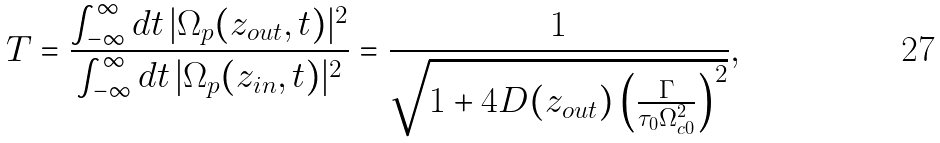<formula> <loc_0><loc_0><loc_500><loc_500>T = \frac { \int _ { - \infty } ^ { \infty } d t \, | \Omega _ { p } ( z _ { o u t } , t ) | ^ { 2 } } { \int _ { - \infty } ^ { \infty } d t \, | \Omega _ { p } ( z _ { i n } , t ) | ^ { 2 } } = \frac { 1 } { \sqrt { 1 + 4 D ( z _ { o u t } ) \left ( \frac { \Gamma } { \tau _ { 0 } \Omega _ { c 0 } ^ { 2 } } \right ) ^ { 2 } } } ,</formula> 